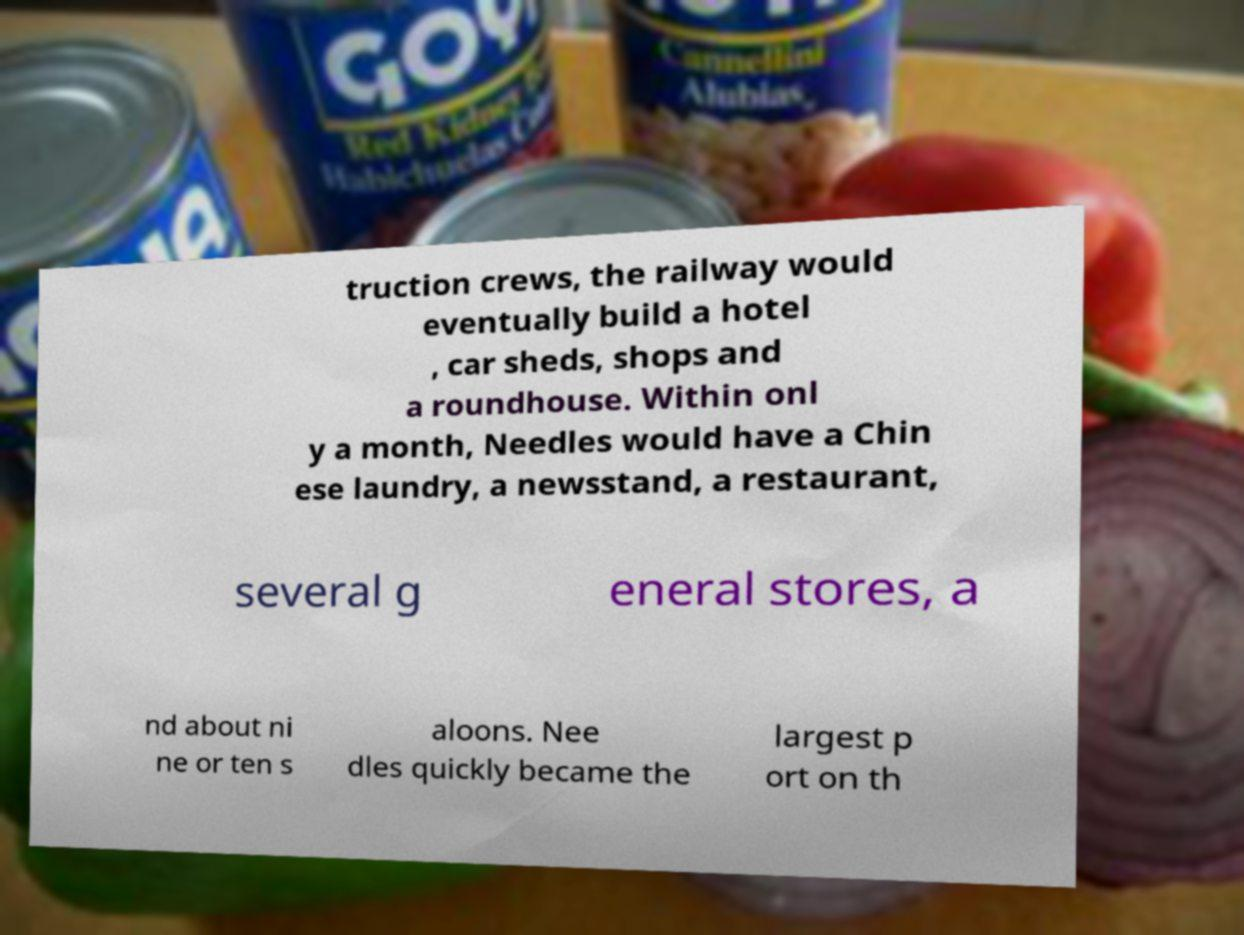Please read and relay the text visible in this image. What does it say? truction crews, the railway would eventually build a hotel , car sheds, shops and a roundhouse. Within onl y a month, Needles would have a Chin ese laundry, a newsstand, a restaurant, several g eneral stores, a nd about ni ne or ten s aloons. Nee dles quickly became the largest p ort on th 